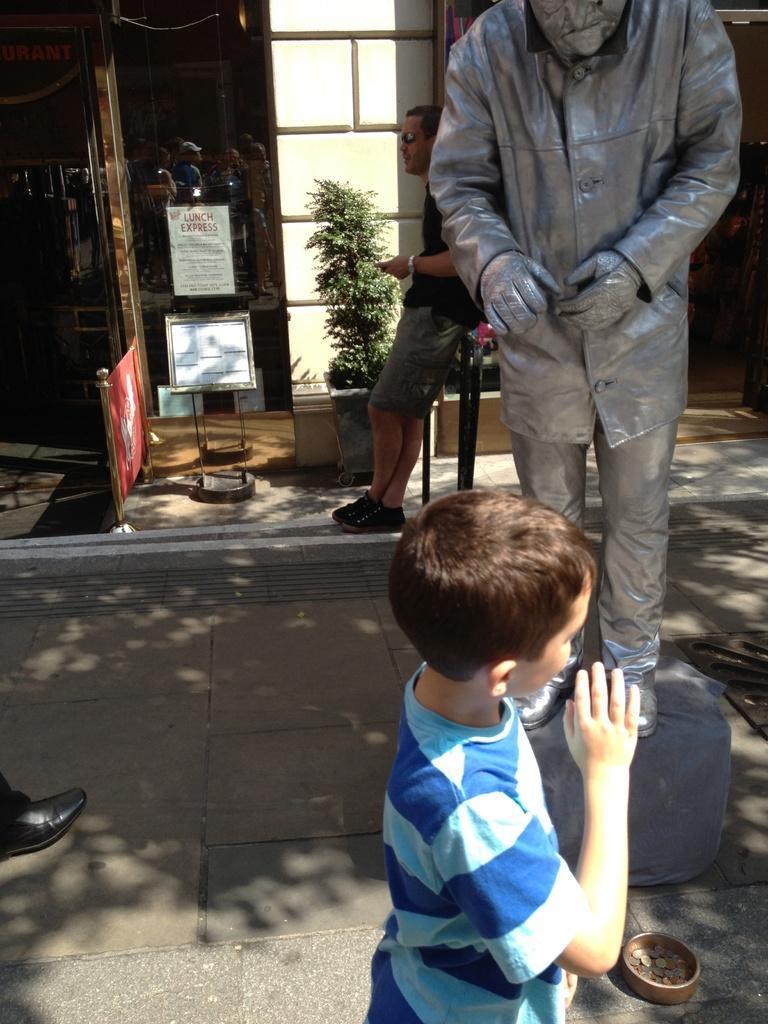How would you summarize this image in a sentence or two? At the bottom a boy is there on the road, he wore t-shirt. On the right side there is a statue in silver color. In the middle there is a plant and this is the glass wall in this image. 